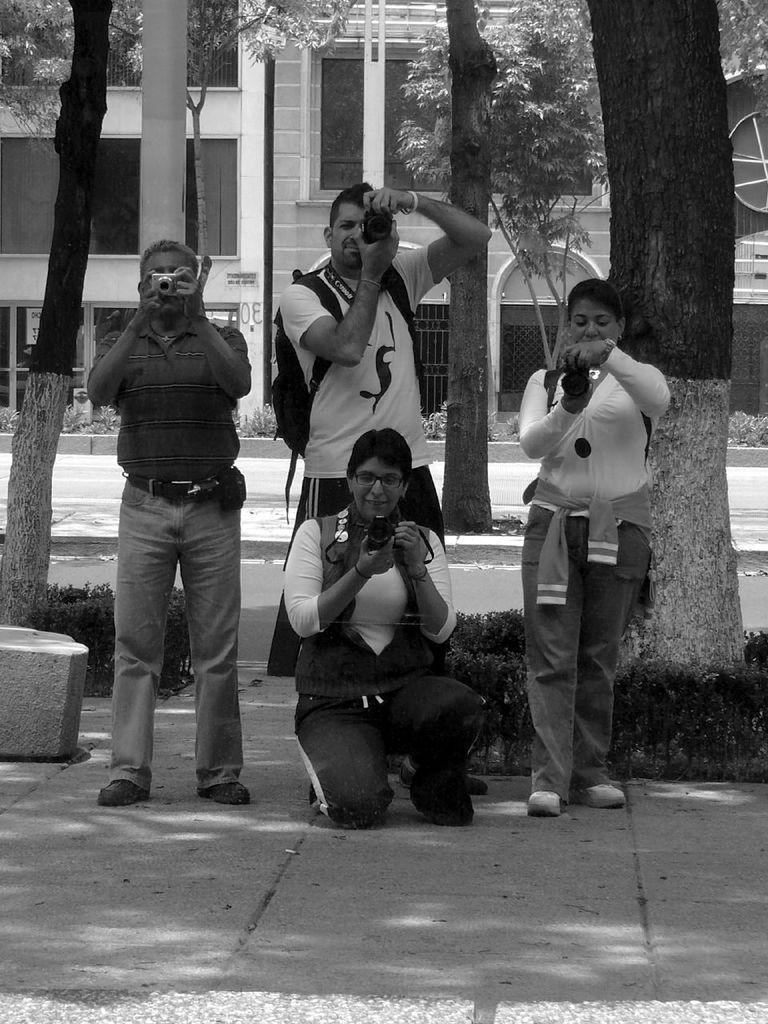In one or two sentences, can you explain what this image depicts? In this picture I can observe four members holding cameras in their hands. Two of them are women and the remaining are men. In the background I can observe trees and a building. This is a black and white image. 